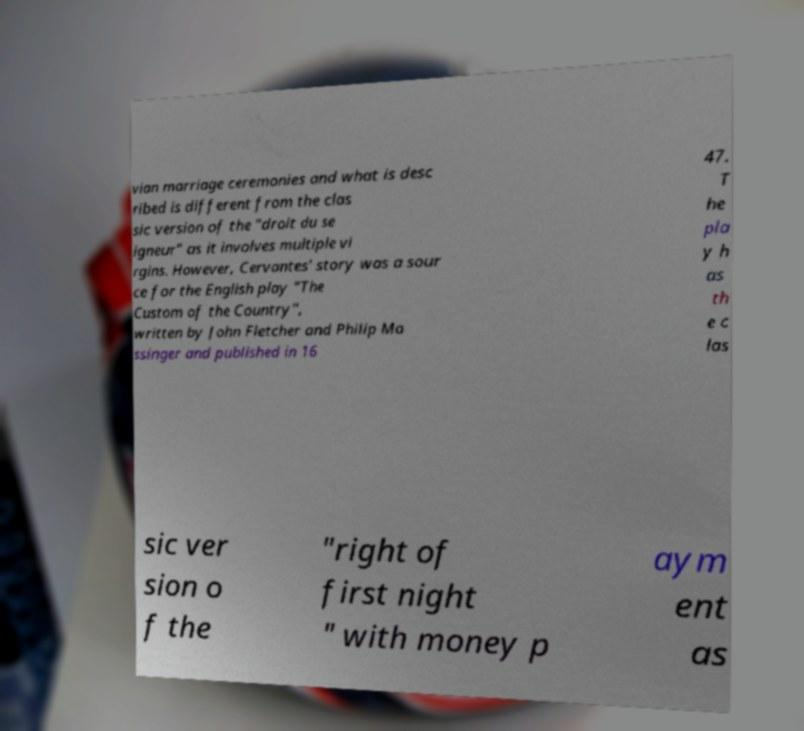There's text embedded in this image that I need extracted. Can you transcribe it verbatim? vian marriage ceremonies and what is desc ribed is different from the clas sic version of the "droit du se igneur" as it involves multiple vi rgins. However, Cervantes' story was a sour ce for the English play "The Custom of the Country", written by John Fletcher and Philip Ma ssinger and published in 16 47. T he pla y h as th e c las sic ver sion o f the "right of first night " with money p aym ent as 